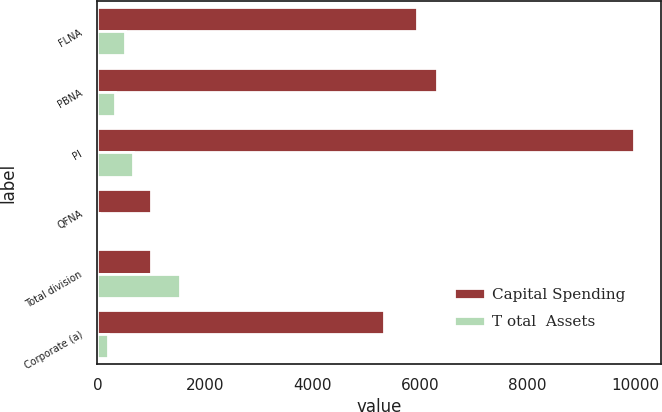Convert chart. <chart><loc_0><loc_0><loc_500><loc_500><stacked_bar_chart><ecel><fcel>FLNA<fcel>PBNA<fcel>PI<fcel>QFNA<fcel>Total division<fcel>Corporate (a)<nl><fcel>Capital Spending<fcel>5948<fcel>6316<fcel>9983<fcel>989<fcel>989<fcel>5331<nl><fcel>T otal  Assets<fcel>512<fcel>320<fcel>667<fcel>31<fcel>1530<fcel>206<nl></chart> 